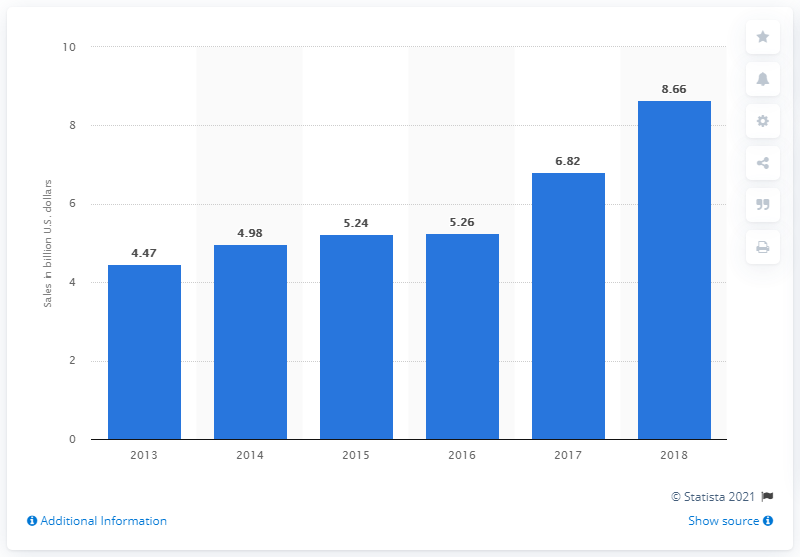Give some essential details in this illustration. In 2018, Rockwell Collins' annual sales were approximately $8.66 billion. The previous year's sales of Rockwell Collins were 6.82 million. 